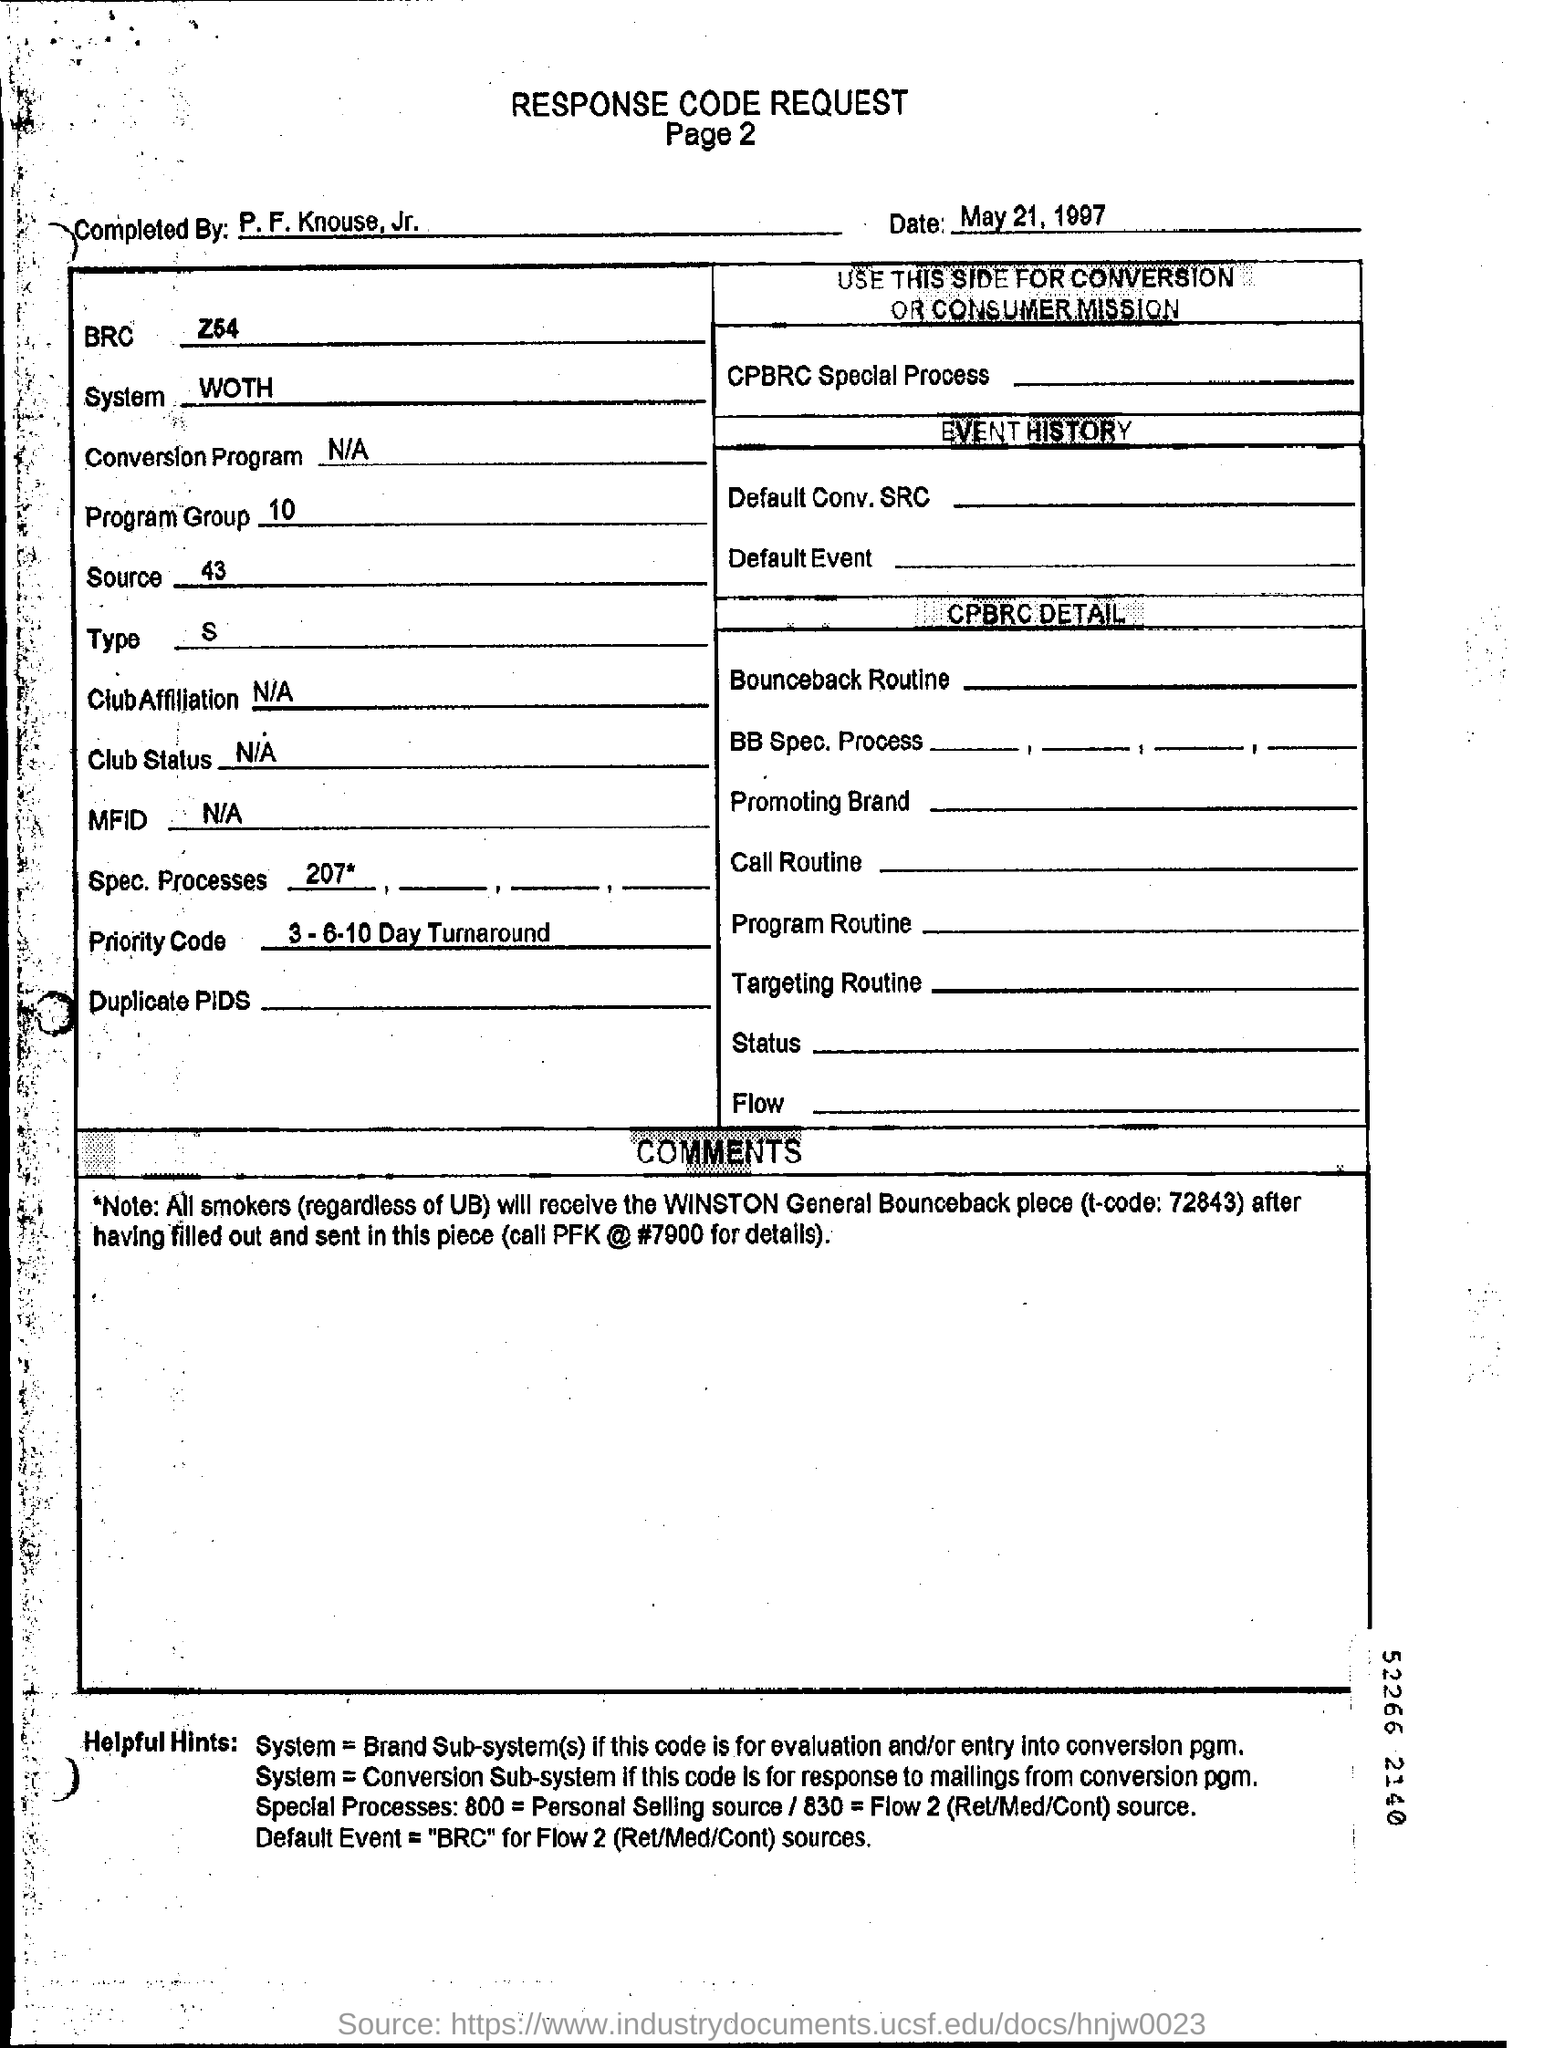What is the date in the response code request form?
Give a very brief answer. May 21, 1997. What is the priority code?
Your answer should be very brief. 3-6-10 Day Turnaround. 